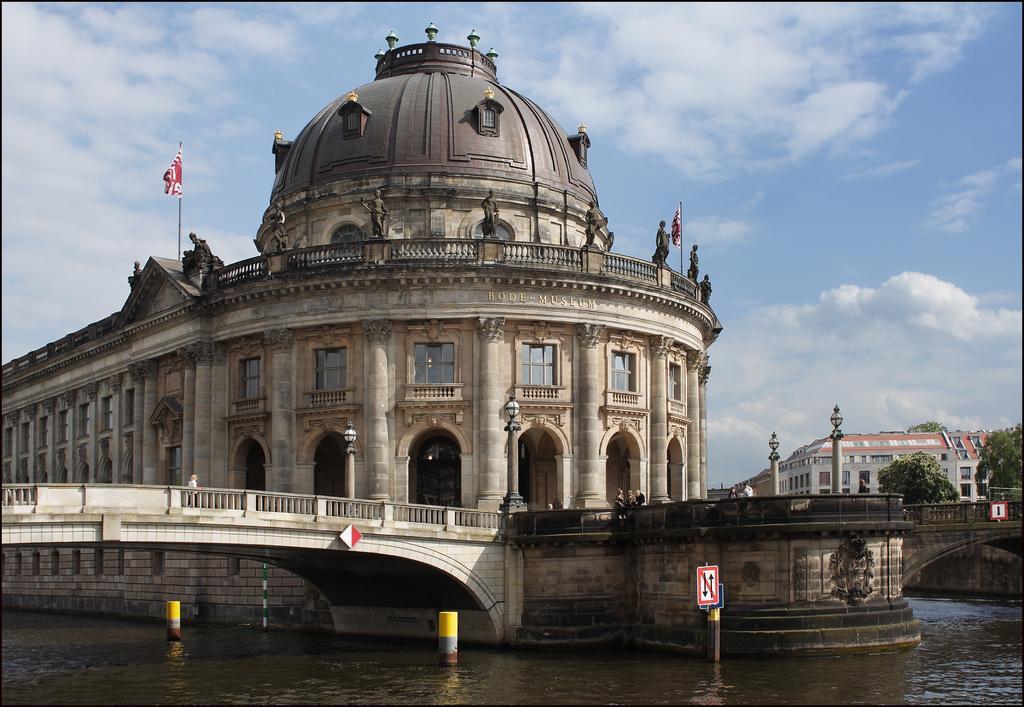Could you give a brief overview of what you see in this image? In this picture we can see water at the bottom, on the left side there is a bridge, in the background we can see buildings, on the right side there are two trees, poles and lights, on the left side there is a flag, there is a sign board in the middle, we can see the sky and clouds at the top of the picture. 